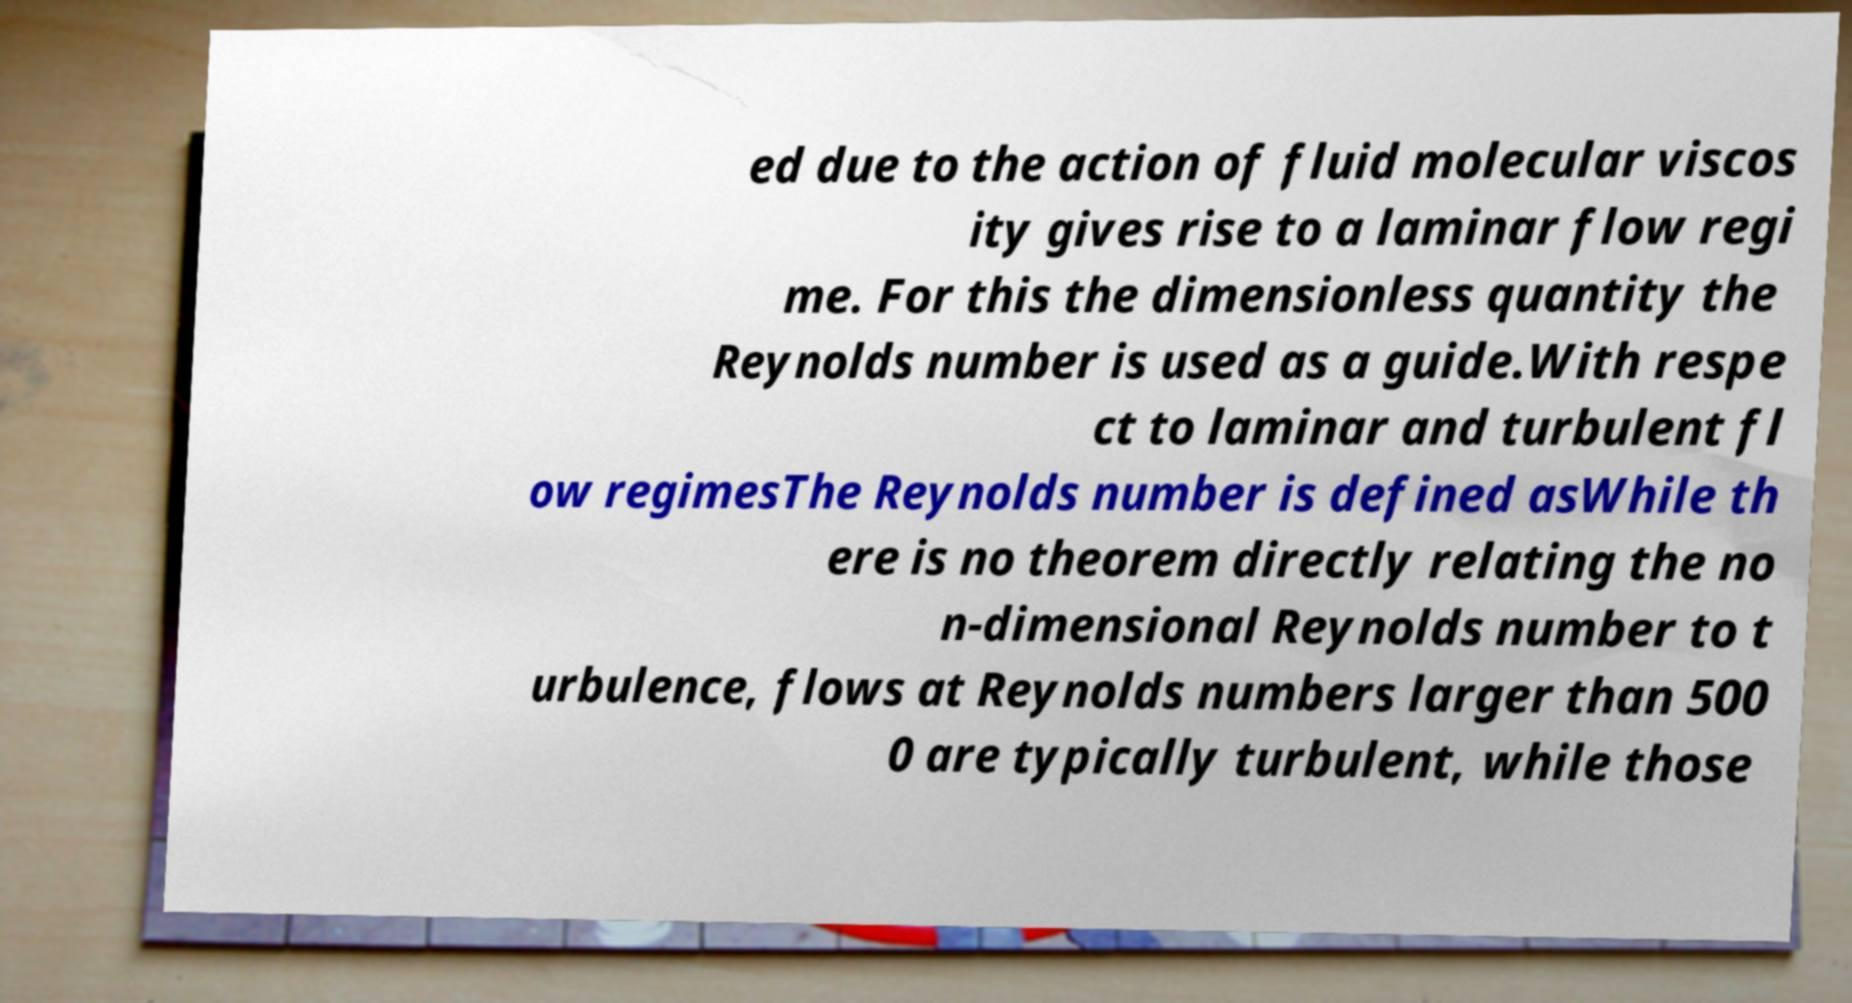For documentation purposes, I need the text within this image transcribed. Could you provide that? ed due to the action of fluid molecular viscos ity gives rise to a laminar flow regi me. For this the dimensionless quantity the Reynolds number is used as a guide.With respe ct to laminar and turbulent fl ow regimesThe Reynolds number is defined asWhile th ere is no theorem directly relating the no n-dimensional Reynolds number to t urbulence, flows at Reynolds numbers larger than 500 0 are typically turbulent, while those 